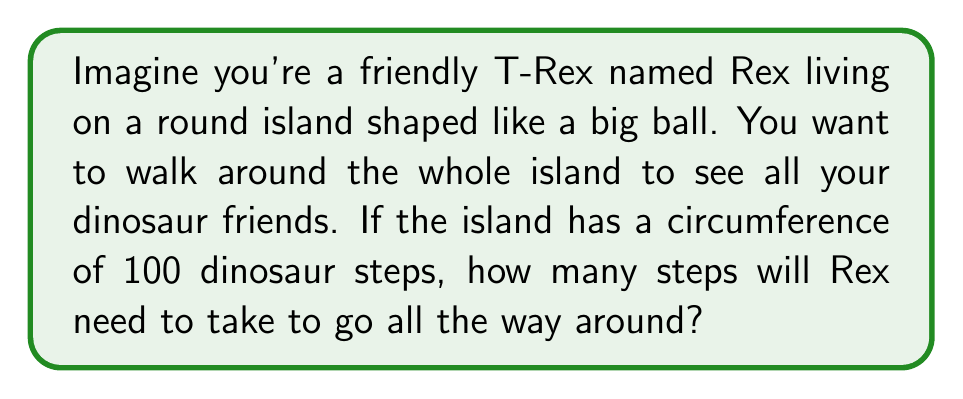Solve this math problem. Let's think about this step-by-step:

1. The island is shaped like a ball, which in math terms is called a sphere.

2. When we walk around a sphere, the shortest path is called a "great circle". It's like drawing the biggest circle possible on the surface of the ball.

3. The question tells us that the circumference of the island is 100 dinosaur steps. The circumference is the distance around the great circle.

4. Since Rex wants to walk all the way around the island, he needs to walk the entire circumference.

5. So, the number of steps Rex needs to take is the same as the circumference of the island.

Therefore, Rex will need to take 100 dinosaur steps to walk all the way around the spherical island.

[asy]
import geometry;

size(200);
pair O = (0,0);
draw(circle(O, 1), blue);
label("Rex's Island", O, fontsize(10));
draw(arc(O, 1, 0, 60), red, Arrow);
label("Rex's Path", (1.2,0.6), red, fontsize(8));
[/asy]
Answer: 100 dinosaur steps 